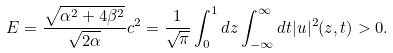<formula> <loc_0><loc_0><loc_500><loc_500>E = \frac { \sqrt { \alpha ^ { 2 } + 4 \beta ^ { 2 } } } { \sqrt { 2 \alpha } } c ^ { 2 } = \frac { 1 } { \sqrt { \pi } } \int _ { 0 } ^ { 1 } d z \int _ { - \infty } ^ { \infty } d t | u | ^ { 2 } ( z , t ) > 0 .</formula> 